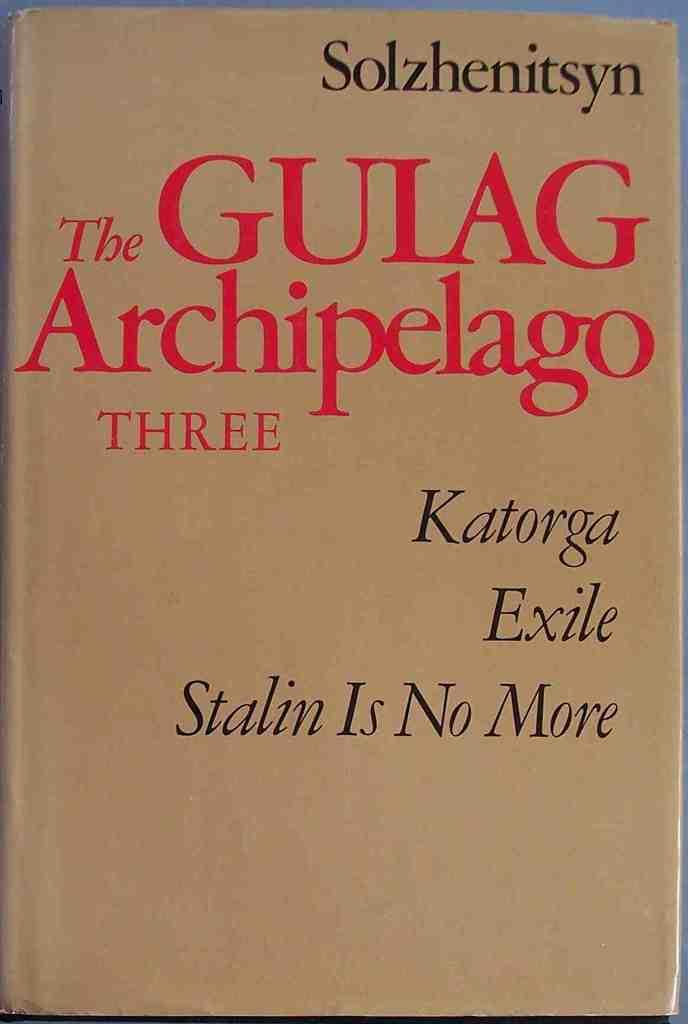Provide a one-sentence caption for the provided image. A brown covered book with the title The Gulag Archipelago Three. 